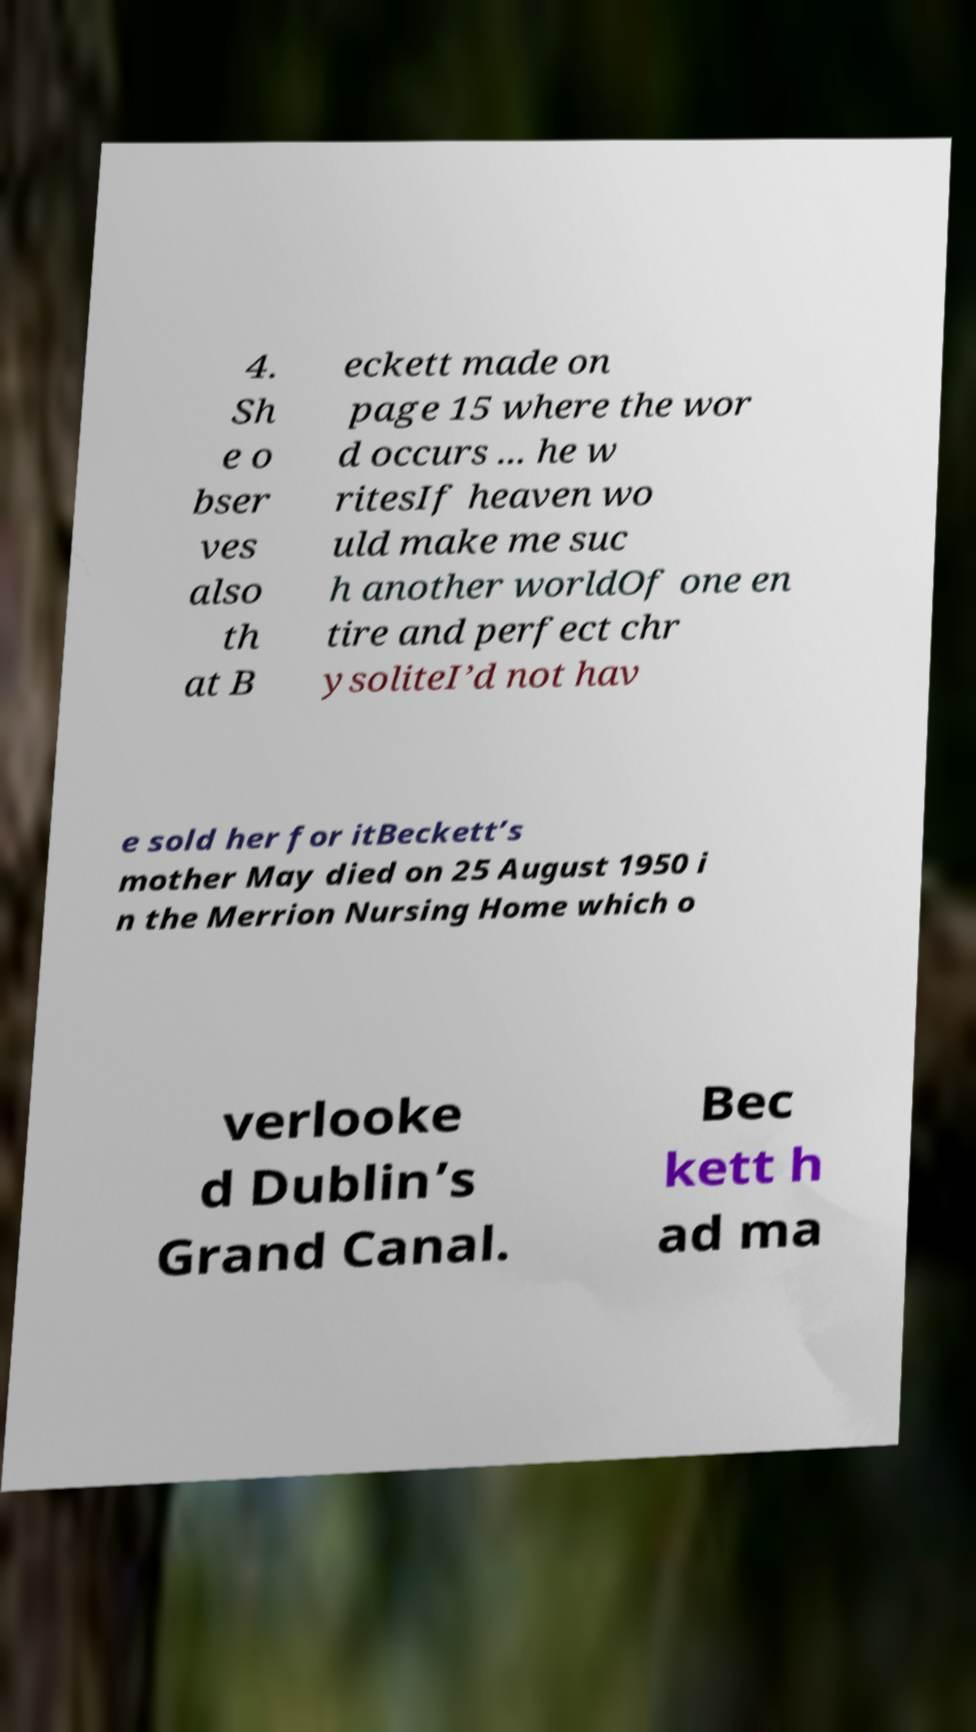Could you assist in decoding the text presented in this image and type it out clearly? 4. Sh e o bser ves also th at B eckett made on page 15 where the wor d occurs ... he w ritesIf heaven wo uld make me suc h another worldOf one en tire and perfect chr ysoliteI’d not hav e sold her for itBeckett’s mother May died on 25 August 1950 i n the Merrion Nursing Home which o verlooke d Dublin’s Grand Canal. Bec kett h ad ma 